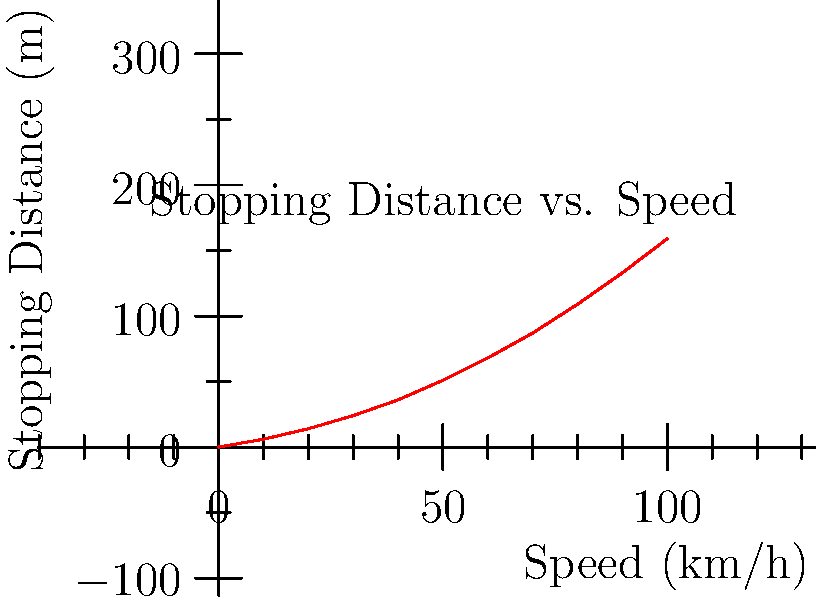A car is traveling at 60 km/h on a wet road. Using the graph provided, which shows the relationship between speed and stopping distance, calculate the total stopping distance. If the car's speed were reduced by 20%, how much shorter would the stopping distance be? Express your answer as a percentage reduction in stopping distance. To solve this problem, we'll follow these steps:

1. Find the stopping distance at 60 km/h:
   From the graph, we can see that at 60 km/h, the stopping distance is approximately 68 meters.

2. Calculate 80% of 60 km/h:
   $80\% \times 60 \text{ km/h} = 0.8 \times 60 = 48 \text{ km/h}$

3. Find the stopping distance at 48 km/h:
   From the graph, we can estimate that at 48 km/h, the stopping distance is about 46 meters.

4. Calculate the difference in stopping distances:
   $68 \text{ m} - 46 \text{ m} = 22 \text{ m}$

5. Calculate the percentage reduction:
   $$\text{Percentage reduction} = \frac{\text{Difference}}{\text{Original distance}} \times 100\%$$
   $$= \frac{22 \text{ m}}{68 \text{ m}} \times 100\% \approx 32.35\%$$

Therefore, reducing the speed by 20% would result in approximately a 32.35% reduction in stopping distance.
Answer: 32.35% 